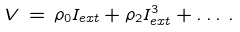<formula> <loc_0><loc_0><loc_500><loc_500>V \, = \, \rho _ { 0 } I _ { e x t } + \rho _ { 2 } I _ { e x t } ^ { 3 } + \dots \, .</formula> 